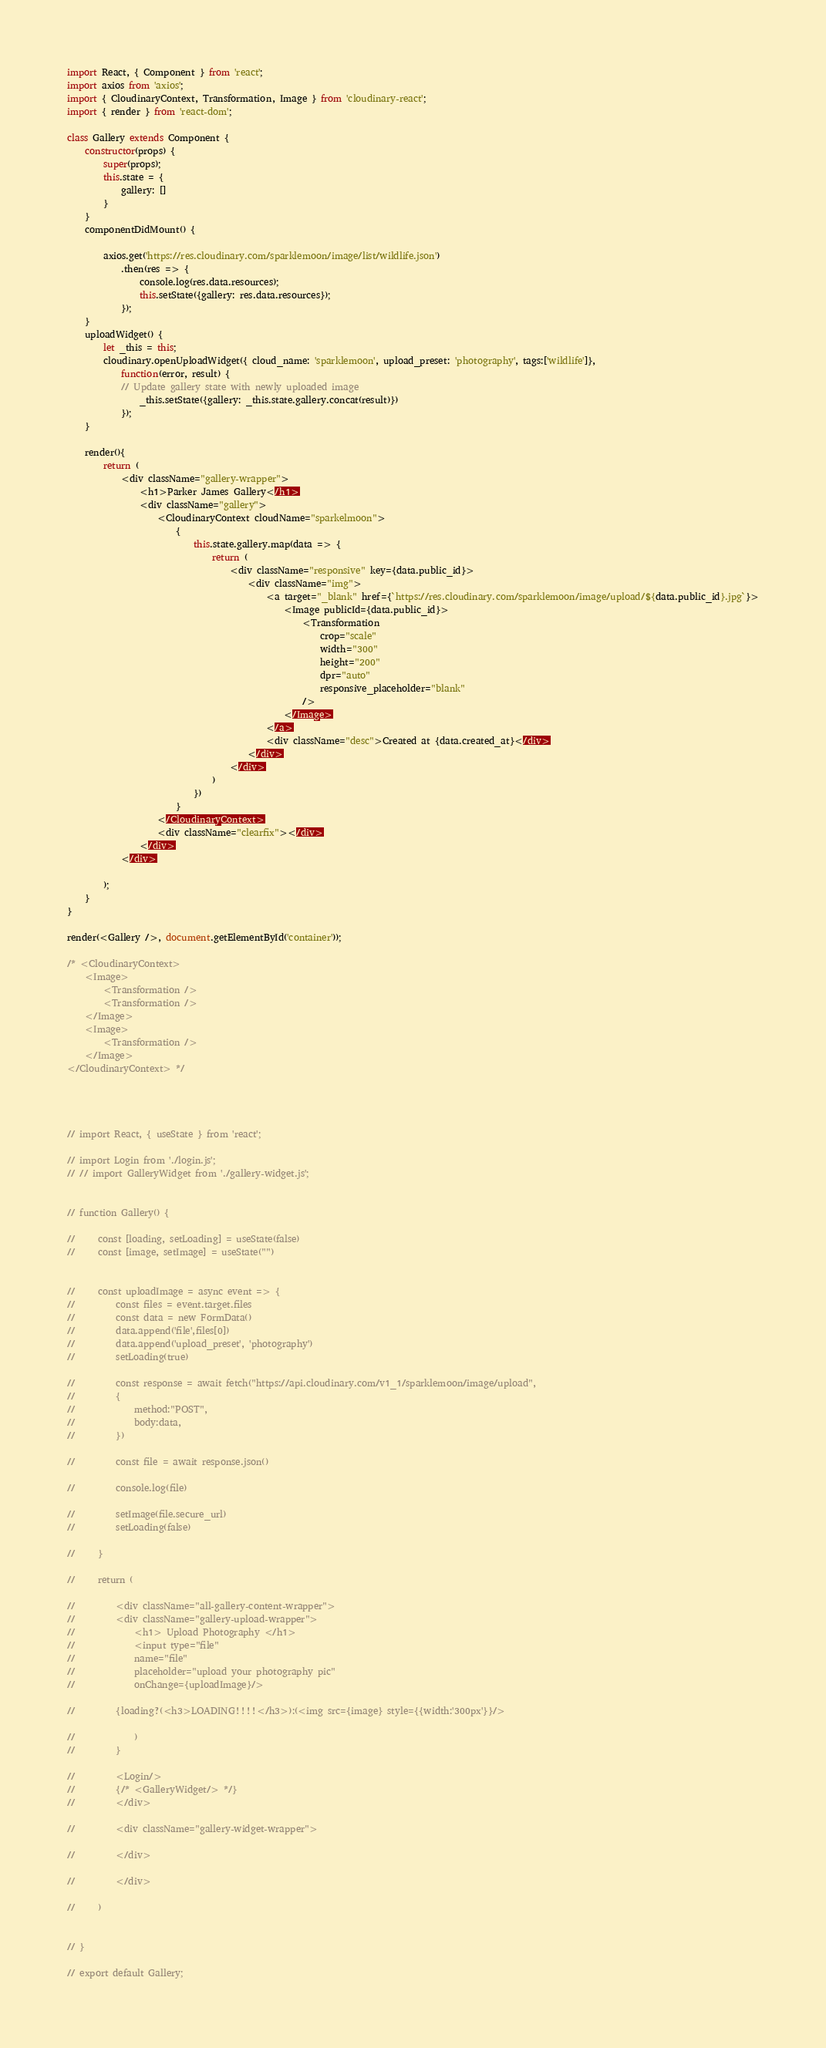<code> <loc_0><loc_0><loc_500><loc_500><_JavaScript_>import React, { Component } from 'react';
import axios from 'axios';
import { CloudinaryContext, Transformation, Image } from 'cloudinary-react';
import { render } from 'react-dom';

class Gallery extends Component {
    constructor(props) {
        super(props);
        this.state = {
            gallery: []
        }
    }
    componentDidMount() {
              
        axios.get('https://res.cloudinary.com/sparklemoon/image/list/wildlife.json')
            .then(res => {
                console.log(res.data.resources);
                this.setState({gallery: res.data.resources});
            });
    }
    uploadWidget() {
        let _this = this;
        cloudinary.openUploadWidget({ cloud_name: 'sparklemoon', upload_preset: 'photography', tags:['wildlife']},
            function(error, result) {
            // Update gallery state with newly uploaded image
                _this.setState({gallery: _this.state.gallery.concat(result)})
            });
    }
    
    render(){
        return (
            <div className="gallery-wrapper">
                <h1>Parker James Gallery</h1>
                <div className="gallery">
                    <CloudinaryContext cloudName="sparkelmoon">
                        {
                            this.state.gallery.map(data => {
                                return (
                                    <div className="responsive" key={data.public_id}>
                                        <div className="img">
                                            <a target="_blank" href={`https://res.cloudinary.com/sparklemoon/image/upload/${data.public_id}.jpg`}>
                                                <Image publicId={data.public_id}>
                                                    <Transformation
                                                        crop="scale"
                                                        width="300"
                                                        height="200"
                                                        dpr="auto"
                                                        responsive_placeholder="blank"
                                                    />
                                                </Image>
                                            </a>
                                            <div className="desc">Created at {data.created_at}</div>
                                        </div>
                                    </div>
                                )
                            })
                        }
                    </CloudinaryContext>
                    <div className="clearfix"></div>
                </div>
            </div>

        );
    }
}

render(<Gallery />, document.getElementById('container'));

/* <CloudinaryContext>
    <Image>
        <Transformation />
        <Transformation />
    </Image>
    <Image>
        <Transformation />
    </Image>
</CloudinaryContext> */




// import React, { useState } from 'react';

// import Login from './login.js';
// // import GalleryWidget from './gallery-widget.js';


// function Gallery() {

//     const [loading, setLoading] = useState(false)
//     const [image, setImage] = useState("")
    

//     const uploadImage = async event => {
//         const files = event.target.files
//         const data = new FormData()
//         data.append('file',files[0])
//         data.append('upload_preset', 'photography')
//         setLoading(true)

//         const response = await fetch("https://api.cloudinary.com/v1_1/sparklemoon/image/upload",
//         {
//             method:"POST",
//             body:data,
//         })

//         const file = await response.json()

//         console.log(file)

//         setImage(file.secure_url)
//         setLoading(false)

//     }

//     return (
        
//         <div className="all-gallery-content-wrapper">
//         <div className="gallery-upload-wrapper">
//             <h1> Upload Photography </h1>
//             <input type="file"
//             name="file"
//             placeholder="upload your photography pic"
//             onChange={uploadImage}/>
        
//         {loading?(<h3>LOADING!!!!</h3>):(<img src={image} style={{width:'300px'}}/>

//             ) 
//         }
        
//         <Login/>
//         {/* <GalleryWidget/> */}
//         </div>

//         <div className="gallery-widget-wrapper">
        
//         </div>

//         </div>
            
//     )

              
// }

// export default Gallery;
</code> 